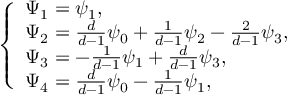<formula> <loc_0><loc_0><loc_500><loc_500>\left \{ \begin{array} { l l } { \Psi _ { 1 } = \psi _ { 1 } , } \\ { \Psi _ { 2 } = \frac { d } { d - 1 } \psi _ { 0 } + \frac { 1 } { d - 1 } \psi _ { 2 } - \frac { 2 } { d - 1 } \psi _ { 3 } , } \\ { \Psi _ { 3 } = - \frac { 1 } { d - 1 } \psi _ { 1 } + \frac { d } { d - 1 } \psi _ { 3 } , } \\ { \Psi _ { 4 } = \frac { d } { d - 1 } \psi _ { 0 } - \frac { 1 } { d - 1 } \psi _ { 1 } , } \end{array}</formula> 